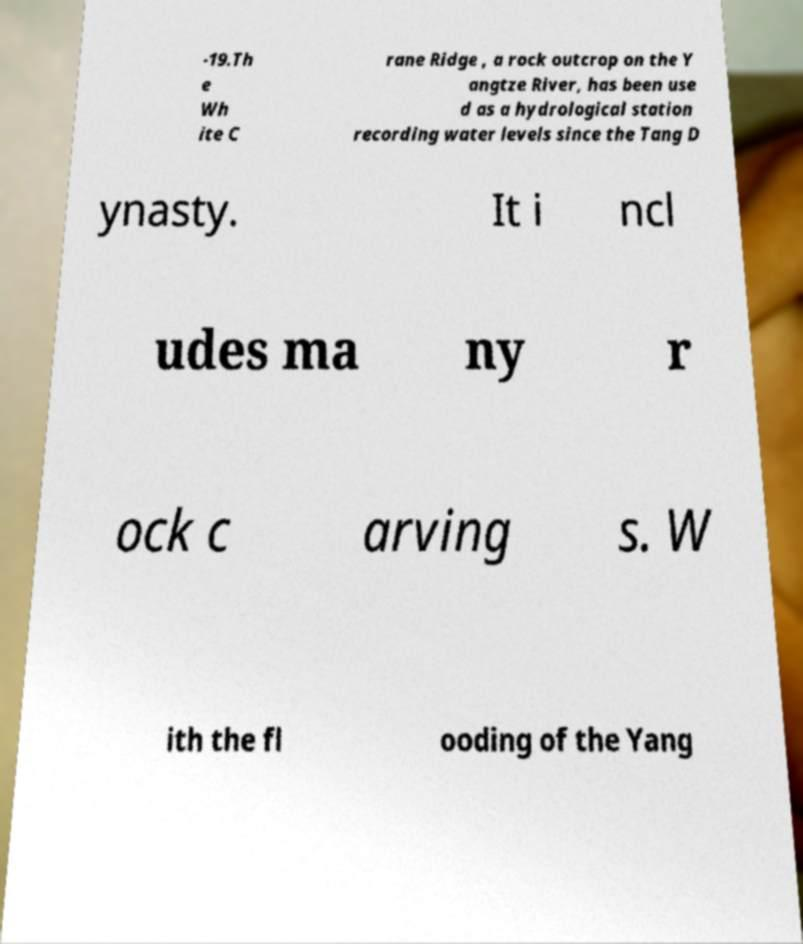I need the written content from this picture converted into text. Can you do that? -19.Th e Wh ite C rane Ridge , a rock outcrop on the Y angtze River, has been use d as a hydrological station recording water levels since the Tang D ynasty. It i ncl udes ma ny r ock c arving s. W ith the fl ooding of the Yang 